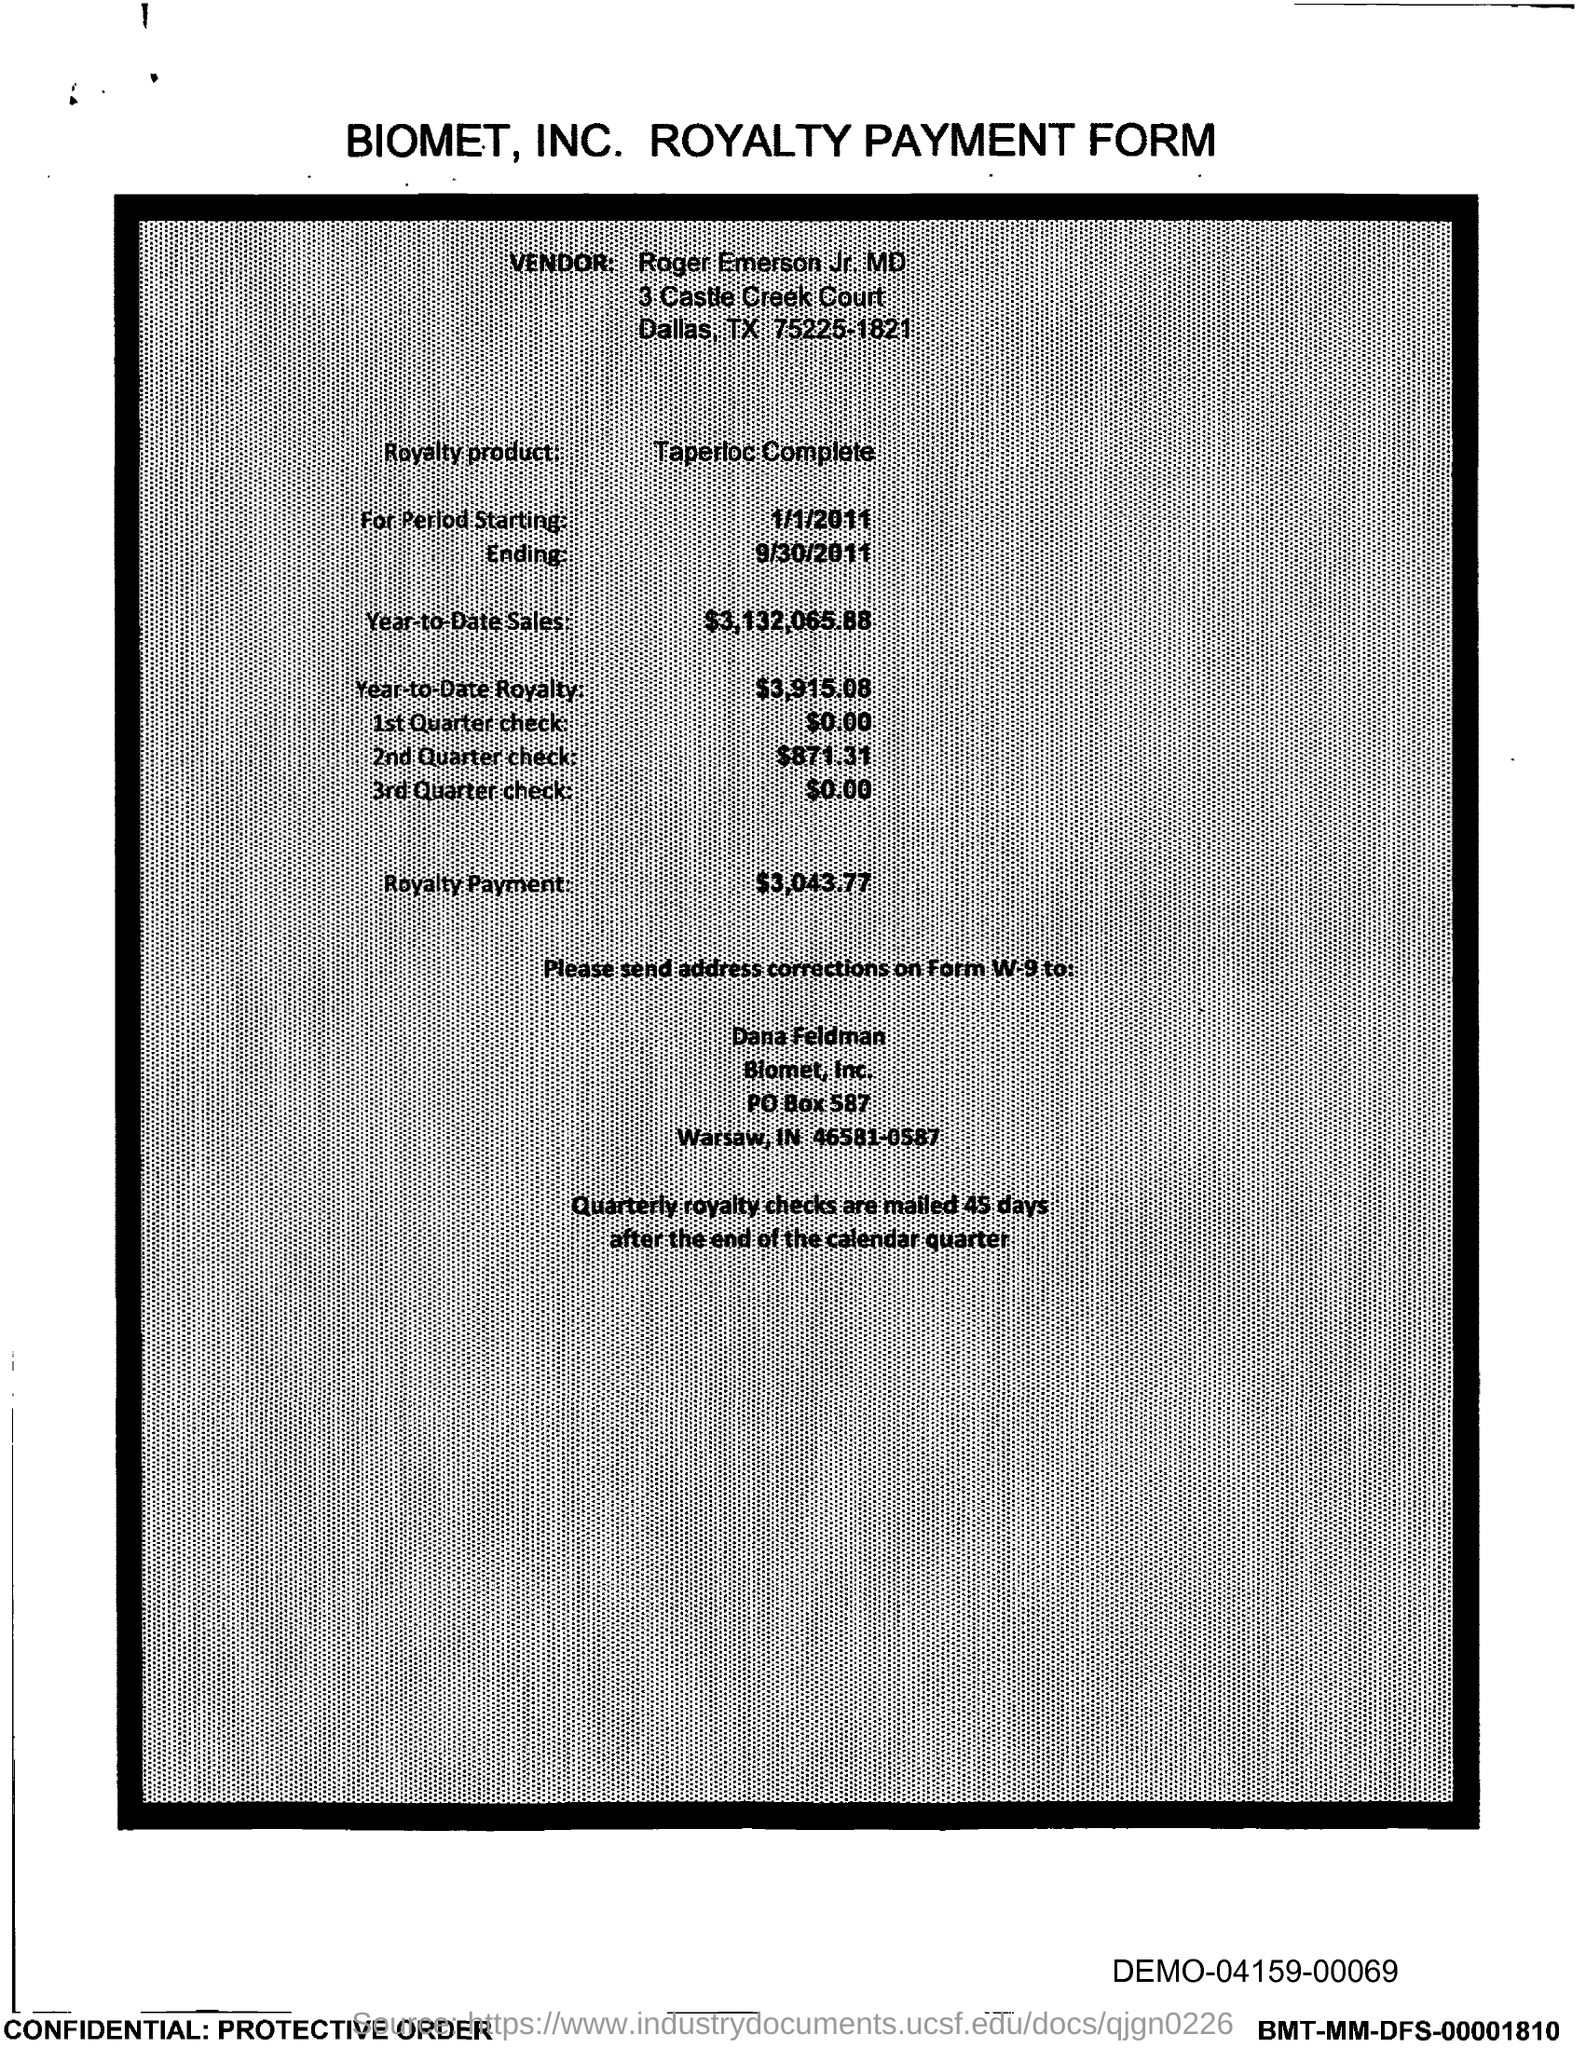Outline some significant characteristics in this image. The PO Box number mentioned in the document is 587. 